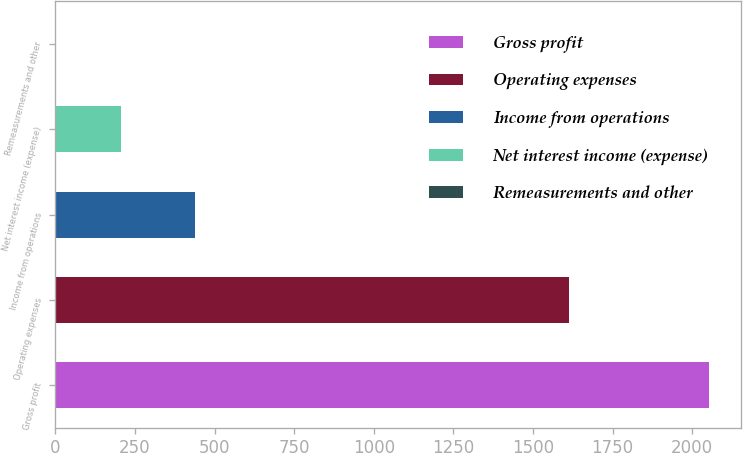<chart> <loc_0><loc_0><loc_500><loc_500><bar_chart><fcel>Gross profit<fcel>Operating expenses<fcel>Income from operations<fcel>Net interest income (expense)<fcel>Remeasurements and other<nl><fcel>2052<fcel>1612<fcel>440<fcel>206.1<fcel>1<nl></chart> 